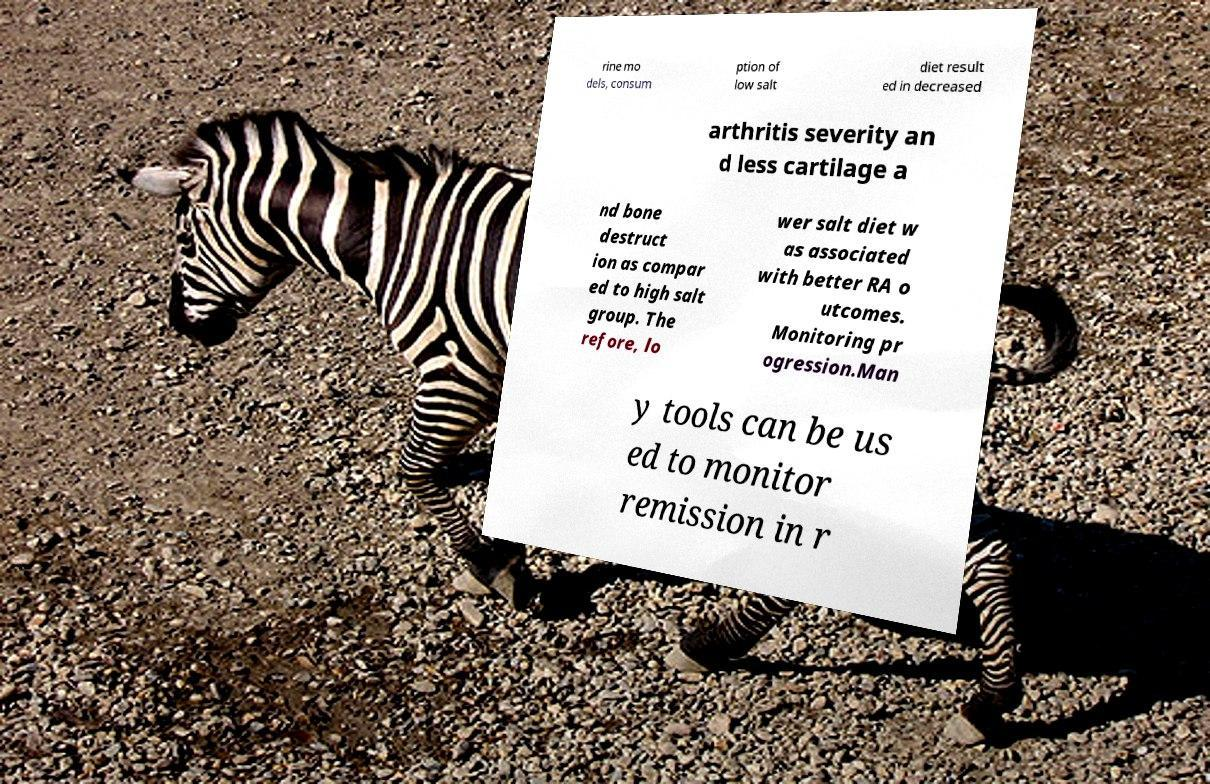Please read and relay the text visible in this image. What does it say? rine mo dels, consum ption of low salt diet result ed in decreased arthritis severity an d less cartilage a nd bone destruct ion as compar ed to high salt group. The refore, lo wer salt diet w as associated with better RA o utcomes. Monitoring pr ogression.Man y tools can be us ed to monitor remission in r 